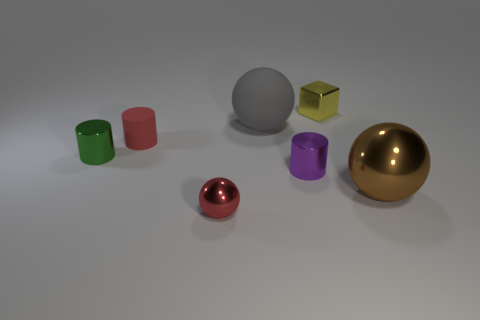Subtract all tiny metal cylinders. How many cylinders are left? 1 Add 2 large gray objects. How many objects exist? 9 Subtract all red cylinders. How many cylinders are left? 2 Subtract all cyan cylinders. Subtract all green spheres. How many cylinders are left? 3 Subtract all purple spheres. How many red cylinders are left? 1 Add 4 gray spheres. How many gray spheres are left? 5 Add 1 large blue matte things. How many large blue matte things exist? 1 Subtract 0 yellow spheres. How many objects are left? 7 Subtract all blocks. How many objects are left? 6 Subtract 3 spheres. How many spheres are left? 0 